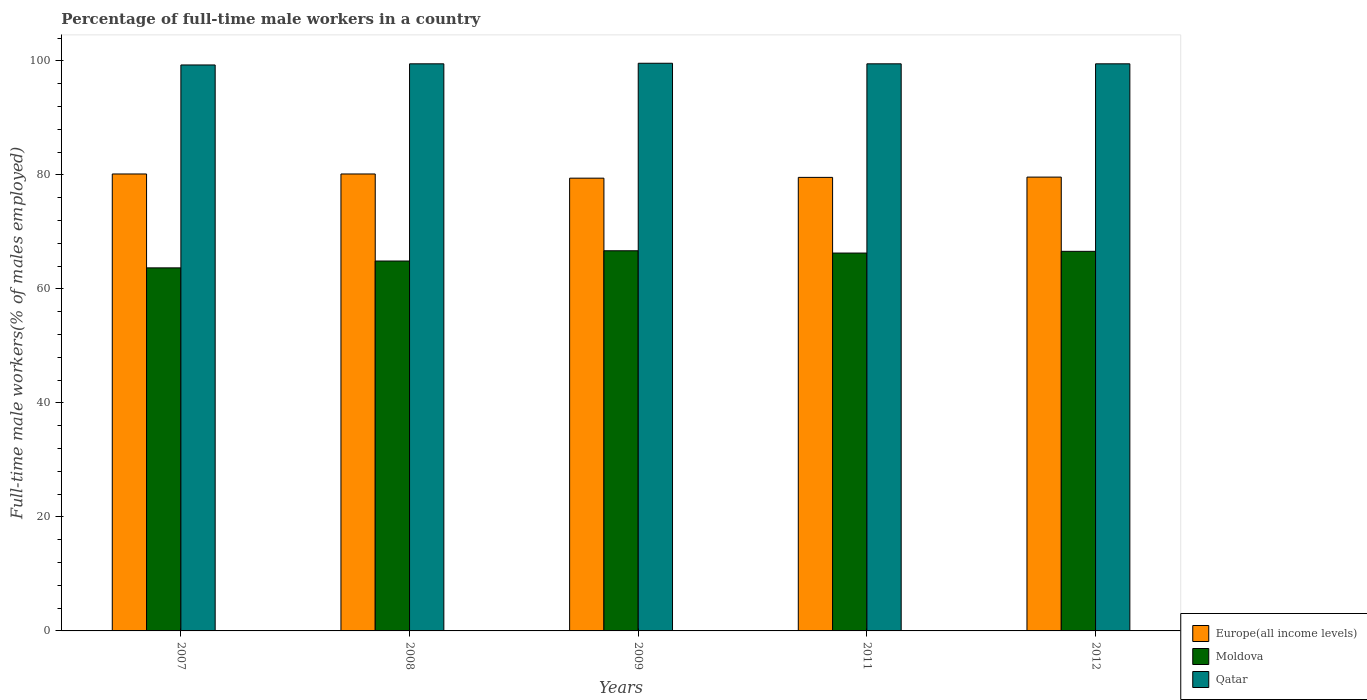How many different coloured bars are there?
Keep it short and to the point. 3. How many groups of bars are there?
Keep it short and to the point. 5. How many bars are there on the 4th tick from the left?
Provide a short and direct response. 3. What is the percentage of full-time male workers in Moldova in 2007?
Your response must be concise. 63.7. Across all years, what is the maximum percentage of full-time male workers in Qatar?
Give a very brief answer. 99.6. Across all years, what is the minimum percentage of full-time male workers in Europe(all income levels)?
Your answer should be compact. 79.44. In which year was the percentage of full-time male workers in Europe(all income levels) maximum?
Make the answer very short. 2007. What is the total percentage of full-time male workers in Europe(all income levels) in the graph?
Offer a terse response. 398.99. What is the difference between the percentage of full-time male workers in Moldova in 2009 and that in 2012?
Offer a very short reply. 0.1. What is the difference between the percentage of full-time male workers in Moldova in 2008 and the percentage of full-time male workers in Qatar in 2012?
Your answer should be compact. -34.6. What is the average percentage of full-time male workers in Qatar per year?
Provide a succinct answer. 99.48. In the year 2007, what is the difference between the percentage of full-time male workers in Qatar and percentage of full-time male workers in Europe(all income levels)?
Offer a terse response. 19.13. In how many years, is the percentage of full-time male workers in Europe(all income levels) greater than 68 %?
Keep it short and to the point. 5. What is the ratio of the percentage of full-time male workers in Europe(all income levels) in 2008 to that in 2012?
Provide a short and direct response. 1.01. What is the difference between the highest and the second highest percentage of full-time male workers in Europe(all income levels)?
Give a very brief answer. 0. What is the difference between the highest and the lowest percentage of full-time male workers in Europe(all income levels)?
Keep it short and to the point. 0.74. In how many years, is the percentage of full-time male workers in Moldova greater than the average percentage of full-time male workers in Moldova taken over all years?
Keep it short and to the point. 3. Is the sum of the percentage of full-time male workers in Europe(all income levels) in 2008 and 2011 greater than the maximum percentage of full-time male workers in Moldova across all years?
Give a very brief answer. Yes. What does the 1st bar from the left in 2008 represents?
Provide a short and direct response. Europe(all income levels). What does the 3rd bar from the right in 2012 represents?
Your answer should be compact. Europe(all income levels). How many bars are there?
Keep it short and to the point. 15. How many years are there in the graph?
Ensure brevity in your answer.  5. What is the difference between two consecutive major ticks on the Y-axis?
Your response must be concise. 20. Does the graph contain grids?
Provide a short and direct response. No. Where does the legend appear in the graph?
Ensure brevity in your answer.  Bottom right. How many legend labels are there?
Ensure brevity in your answer.  3. What is the title of the graph?
Keep it short and to the point. Percentage of full-time male workers in a country. What is the label or title of the X-axis?
Your answer should be compact. Years. What is the label or title of the Y-axis?
Provide a short and direct response. Full-time male workers(% of males employed). What is the Full-time male workers(% of males employed) of Europe(all income levels) in 2007?
Give a very brief answer. 80.17. What is the Full-time male workers(% of males employed) of Moldova in 2007?
Provide a short and direct response. 63.7. What is the Full-time male workers(% of males employed) of Qatar in 2007?
Make the answer very short. 99.3. What is the Full-time male workers(% of males employed) of Europe(all income levels) in 2008?
Your answer should be compact. 80.17. What is the Full-time male workers(% of males employed) of Moldova in 2008?
Offer a terse response. 64.9. What is the Full-time male workers(% of males employed) in Qatar in 2008?
Give a very brief answer. 99.5. What is the Full-time male workers(% of males employed) of Europe(all income levels) in 2009?
Make the answer very short. 79.44. What is the Full-time male workers(% of males employed) in Moldova in 2009?
Ensure brevity in your answer.  66.7. What is the Full-time male workers(% of males employed) in Qatar in 2009?
Ensure brevity in your answer.  99.6. What is the Full-time male workers(% of males employed) of Europe(all income levels) in 2011?
Give a very brief answer. 79.58. What is the Full-time male workers(% of males employed) of Moldova in 2011?
Your response must be concise. 66.3. What is the Full-time male workers(% of males employed) of Qatar in 2011?
Your answer should be compact. 99.5. What is the Full-time male workers(% of males employed) of Europe(all income levels) in 2012?
Your answer should be very brief. 79.63. What is the Full-time male workers(% of males employed) of Moldova in 2012?
Make the answer very short. 66.6. What is the Full-time male workers(% of males employed) in Qatar in 2012?
Your answer should be very brief. 99.5. Across all years, what is the maximum Full-time male workers(% of males employed) in Europe(all income levels)?
Ensure brevity in your answer.  80.17. Across all years, what is the maximum Full-time male workers(% of males employed) of Moldova?
Keep it short and to the point. 66.7. Across all years, what is the maximum Full-time male workers(% of males employed) in Qatar?
Keep it short and to the point. 99.6. Across all years, what is the minimum Full-time male workers(% of males employed) in Europe(all income levels)?
Provide a short and direct response. 79.44. Across all years, what is the minimum Full-time male workers(% of males employed) in Moldova?
Offer a terse response. 63.7. Across all years, what is the minimum Full-time male workers(% of males employed) in Qatar?
Make the answer very short. 99.3. What is the total Full-time male workers(% of males employed) in Europe(all income levels) in the graph?
Your answer should be very brief. 398.99. What is the total Full-time male workers(% of males employed) in Moldova in the graph?
Offer a very short reply. 328.2. What is the total Full-time male workers(% of males employed) in Qatar in the graph?
Make the answer very short. 497.4. What is the difference between the Full-time male workers(% of males employed) of Europe(all income levels) in 2007 and that in 2008?
Keep it short and to the point. 0. What is the difference between the Full-time male workers(% of males employed) of Moldova in 2007 and that in 2008?
Provide a succinct answer. -1.2. What is the difference between the Full-time male workers(% of males employed) of Qatar in 2007 and that in 2008?
Keep it short and to the point. -0.2. What is the difference between the Full-time male workers(% of males employed) in Europe(all income levels) in 2007 and that in 2009?
Provide a succinct answer. 0.74. What is the difference between the Full-time male workers(% of males employed) of Qatar in 2007 and that in 2009?
Ensure brevity in your answer.  -0.3. What is the difference between the Full-time male workers(% of males employed) of Europe(all income levels) in 2007 and that in 2011?
Ensure brevity in your answer.  0.6. What is the difference between the Full-time male workers(% of males employed) in Moldova in 2007 and that in 2011?
Provide a succinct answer. -2.6. What is the difference between the Full-time male workers(% of males employed) of Qatar in 2007 and that in 2011?
Ensure brevity in your answer.  -0.2. What is the difference between the Full-time male workers(% of males employed) of Europe(all income levels) in 2007 and that in 2012?
Provide a succinct answer. 0.55. What is the difference between the Full-time male workers(% of males employed) in Moldova in 2007 and that in 2012?
Provide a short and direct response. -2.9. What is the difference between the Full-time male workers(% of males employed) in Europe(all income levels) in 2008 and that in 2009?
Give a very brief answer. 0.74. What is the difference between the Full-time male workers(% of males employed) in Moldova in 2008 and that in 2009?
Keep it short and to the point. -1.8. What is the difference between the Full-time male workers(% of males employed) of Europe(all income levels) in 2008 and that in 2011?
Provide a succinct answer. 0.6. What is the difference between the Full-time male workers(% of males employed) of Moldova in 2008 and that in 2011?
Keep it short and to the point. -1.4. What is the difference between the Full-time male workers(% of males employed) in Qatar in 2008 and that in 2011?
Your response must be concise. 0. What is the difference between the Full-time male workers(% of males employed) of Europe(all income levels) in 2008 and that in 2012?
Offer a very short reply. 0.55. What is the difference between the Full-time male workers(% of males employed) in Moldova in 2008 and that in 2012?
Offer a very short reply. -1.7. What is the difference between the Full-time male workers(% of males employed) in Europe(all income levels) in 2009 and that in 2011?
Your answer should be very brief. -0.14. What is the difference between the Full-time male workers(% of males employed) in Europe(all income levels) in 2009 and that in 2012?
Keep it short and to the point. -0.19. What is the difference between the Full-time male workers(% of males employed) in Europe(all income levels) in 2011 and that in 2012?
Keep it short and to the point. -0.05. What is the difference between the Full-time male workers(% of males employed) of Europe(all income levels) in 2007 and the Full-time male workers(% of males employed) of Moldova in 2008?
Your response must be concise. 15.27. What is the difference between the Full-time male workers(% of males employed) of Europe(all income levels) in 2007 and the Full-time male workers(% of males employed) of Qatar in 2008?
Your answer should be compact. -19.33. What is the difference between the Full-time male workers(% of males employed) of Moldova in 2007 and the Full-time male workers(% of males employed) of Qatar in 2008?
Give a very brief answer. -35.8. What is the difference between the Full-time male workers(% of males employed) in Europe(all income levels) in 2007 and the Full-time male workers(% of males employed) in Moldova in 2009?
Make the answer very short. 13.47. What is the difference between the Full-time male workers(% of males employed) in Europe(all income levels) in 2007 and the Full-time male workers(% of males employed) in Qatar in 2009?
Ensure brevity in your answer.  -19.43. What is the difference between the Full-time male workers(% of males employed) of Moldova in 2007 and the Full-time male workers(% of males employed) of Qatar in 2009?
Make the answer very short. -35.9. What is the difference between the Full-time male workers(% of males employed) of Europe(all income levels) in 2007 and the Full-time male workers(% of males employed) of Moldova in 2011?
Give a very brief answer. 13.87. What is the difference between the Full-time male workers(% of males employed) of Europe(all income levels) in 2007 and the Full-time male workers(% of males employed) of Qatar in 2011?
Ensure brevity in your answer.  -19.33. What is the difference between the Full-time male workers(% of males employed) of Moldova in 2007 and the Full-time male workers(% of males employed) of Qatar in 2011?
Provide a succinct answer. -35.8. What is the difference between the Full-time male workers(% of males employed) of Europe(all income levels) in 2007 and the Full-time male workers(% of males employed) of Moldova in 2012?
Your response must be concise. 13.57. What is the difference between the Full-time male workers(% of males employed) of Europe(all income levels) in 2007 and the Full-time male workers(% of males employed) of Qatar in 2012?
Offer a terse response. -19.33. What is the difference between the Full-time male workers(% of males employed) of Moldova in 2007 and the Full-time male workers(% of males employed) of Qatar in 2012?
Provide a succinct answer. -35.8. What is the difference between the Full-time male workers(% of males employed) in Europe(all income levels) in 2008 and the Full-time male workers(% of males employed) in Moldova in 2009?
Your response must be concise. 13.47. What is the difference between the Full-time male workers(% of males employed) in Europe(all income levels) in 2008 and the Full-time male workers(% of males employed) in Qatar in 2009?
Offer a very short reply. -19.43. What is the difference between the Full-time male workers(% of males employed) in Moldova in 2008 and the Full-time male workers(% of males employed) in Qatar in 2009?
Give a very brief answer. -34.7. What is the difference between the Full-time male workers(% of males employed) in Europe(all income levels) in 2008 and the Full-time male workers(% of males employed) in Moldova in 2011?
Give a very brief answer. 13.87. What is the difference between the Full-time male workers(% of males employed) in Europe(all income levels) in 2008 and the Full-time male workers(% of males employed) in Qatar in 2011?
Give a very brief answer. -19.33. What is the difference between the Full-time male workers(% of males employed) of Moldova in 2008 and the Full-time male workers(% of males employed) of Qatar in 2011?
Your answer should be very brief. -34.6. What is the difference between the Full-time male workers(% of males employed) of Europe(all income levels) in 2008 and the Full-time male workers(% of males employed) of Moldova in 2012?
Make the answer very short. 13.57. What is the difference between the Full-time male workers(% of males employed) in Europe(all income levels) in 2008 and the Full-time male workers(% of males employed) in Qatar in 2012?
Give a very brief answer. -19.33. What is the difference between the Full-time male workers(% of males employed) in Moldova in 2008 and the Full-time male workers(% of males employed) in Qatar in 2012?
Your answer should be very brief. -34.6. What is the difference between the Full-time male workers(% of males employed) in Europe(all income levels) in 2009 and the Full-time male workers(% of males employed) in Moldova in 2011?
Your answer should be very brief. 13.14. What is the difference between the Full-time male workers(% of males employed) in Europe(all income levels) in 2009 and the Full-time male workers(% of males employed) in Qatar in 2011?
Ensure brevity in your answer.  -20.06. What is the difference between the Full-time male workers(% of males employed) of Moldova in 2009 and the Full-time male workers(% of males employed) of Qatar in 2011?
Offer a very short reply. -32.8. What is the difference between the Full-time male workers(% of males employed) of Europe(all income levels) in 2009 and the Full-time male workers(% of males employed) of Moldova in 2012?
Make the answer very short. 12.84. What is the difference between the Full-time male workers(% of males employed) in Europe(all income levels) in 2009 and the Full-time male workers(% of males employed) in Qatar in 2012?
Offer a very short reply. -20.06. What is the difference between the Full-time male workers(% of males employed) in Moldova in 2009 and the Full-time male workers(% of males employed) in Qatar in 2012?
Keep it short and to the point. -32.8. What is the difference between the Full-time male workers(% of males employed) in Europe(all income levels) in 2011 and the Full-time male workers(% of males employed) in Moldova in 2012?
Ensure brevity in your answer.  12.98. What is the difference between the Full-time male workers(% of males employed) of Europe(all income levels) in 2011 and the Full-time male workers(% of males employed) of Qatar in 2012?
Keep it short and to the point. -19.92. What is the difference between the Full-time male workers(% of males employed) of Moldova in 2011 and the Full-time male workers(% of males employed) of Qatar in 2012?
Offer a terse response. -33.2. What is the average Full-time male workers(% of males employed) in Europe(all income levels) per year?
Give a very brief answer. 79.8. What is the average Full-time male workers(% of males employed) of Moldova per year?
Keep it short and to the point. 65.64. What is the average Full-time male workers(% of males employed) in Qatar per year?
Provide a short and direct response. 99.48. In the year 2007, what is the difference between the Full-time male workers(% of males employed) of Europe(all income levels) and Full-time male workers(% of males employed) of Moldova?
Your response must be concise. 16.47. In the year 2007, what is the difference between the Full-time male workers(% of males employed) in Europe(all income levels) and Full-time male workers(% of males employed) in Qatar?
Your answer should be very brief. -19.13. In the year 2007, what is the difference between the Full-time male workers(% of males employed) of Moldova and Full-time male workers(% of males employed) of Qatar?
Your answer should be compact. -35.6. In the year 2008, what is the difference between the Full-time male workers(% of males employed) in Europe(all income levels) and Full-time male workers(% of males employed) in Moldova?
Keep it short and to the point. 15.27. In the year 2008, what is the difference between the Full-time male workers(% of males employed) in Europe(all income levels) and Full-time male workers(% of males employed) in Qatar?
Your response must be concise. -19.33. In the year 2008, what is the difference between the Full-time male workers(% of males employed) in Moldova and Full-time male workers(% of males employed) in Qatar?
Provide a short and direct response. -34.6. In the year 2009, what is the difference between the Full-time male workers(% of males employed) of Europe(all income levels) and Full-time male workers(% of males employed) of Moldova?
Provide a short and direct response. 12.74. In the year 2009, what is the difference between the Full-time male workers(% of males employed) of Europe(all income levels) and Full-time male workers(% of males employed) of Qatar?
Offer a very short reply. -20.16. In the year 2009, what is the difference between the Full-time male workers(% of males employed) in Moldova and Full-time male workers(% of males employed) in Qatar?
Ensure brevity in your answer.  -32.9. In the year 2011, what is the difference between the Full-time male workers(% of males employed) in Europe(all income levels) and Full-time male workers(% of males employed) in Moldova?
Keep it short and to the point. 13.28. In the year 2011, what is the difference between the Full-time male workers(% of males employed) of Europe(all income levels) and Full-time male workers(% of males employed) of Qatar?
Make the answer very short. -19.92. In the year 2011, what is the difference between the Full-time male workers(% of males employed) of Moldova and Full-time male workers(% of males employed) of Qatar?
Make the answer very short. -33.2. In the year 2012, what is the difference between the Full-time male workers(% of males employed) of Europe(all income levels) and Full-time male workers(% of males employed) of Moldova?
Your answer should be very brief. 13.03. In the year 2012, what is the difference between the Full-time male workers(% of males employed) of Europe(all income levels) and Full-time male workers(% of males employed) of Qatar?
Provide a succinct answer. -19.87. In the year 2012, what is the difference between the Full-time male workers(% of males employed) in Moldova and Full-time male workers(% of males employed) in Qatar?
Offer a terse response. -32.9. What is the ratio of the Full-time male workers(% of males employed) of Europe(all income levels) in 2007 to that in 2008?
Provide a short and direct response. 1. What is the ratio of the Full-time male workers(% of males employed) in Moldova in 2007 to that in 2008?
Your answer should be very brief. 0.98. What is the ratio of the Full-time male workers(% of males employed) in Europe(all income levels) in 2007 to that in 2009?
Your response must be concise. 1.01. What is the ratio of the Full-time male workers(% of males employed) of Moldova in 2007 to that in 2009?
Your response must be concise. 0.95. What is the ratio of the Full-time male workers(% of males employed) of Qatar in 2007 to that in 2009?
Your answer should be compact. 1. What is the ratio of the Full-time male workers(% of males employed) in Europe(all income levels) in 2007 to that in 2011?
Provide a succinct answer. 1.01. What is the ratio of the Full-time male workers(% of males employed) of Moldova in 2007 to that in 2011?
Offer a very short reply. 0.96. What is the ratio of the Full-time male workers(% of males employed) of Qatar in 2007 to that in 2011?
Your answer should be very brief. 1. What is the ratio of the Full-time male workers(% of males employed) in Europe(all income levels) in 2007 to that in 2012?
Make the answer very short. 1.01. What is the ratio of the Full-time male workers(% of males employed) of Moldova in 2007 to that in 2012?
Your answer should be compact. 0.96. What is the ratio of the Full-time male workers(% of males employed) of Europe(all income levels) in 2008 to that in 2009?
Give a very brief answer. 1.01. What is the ratio of the Full-time male workers(% of males employed) in Moldova in 2008 to that in 2009?
Your answer should be very brief. 0.97. What is the ratio of the Full-time male workers(% of males employed) of Qatar in 2008 to that in 2009?
Your answer should be very brief. 1. What is the ratio of the Full-time male workers(% of males employed) in Europe(all income levels) in 2008 to that in 2011?
Your answer should be very brief. 1.01. What is the ratio of the Full-time male workers(% of males employed) in Moldova in 2008 to that in 2011?
Provide a succinct answer. 0.98. What is the ratio of the Full-time male workers(% of males employed) in Europe(all income levels) in 2008 to that in 2012?
Your answer should be compact. 1.01. What is the ratio of the Full-time male workers(% of males employed) in Moldova in 2008 to that in 2012?
Ensure brevity in your answer.  0.97. What is the ratio of the Full-time male workers(% of males employed) of Qatar in 2008 to that in 2012?
Provide a succinct answer. 1. What is the ratio of the Full-time male workers(% of males employed) in Moldova in 2009 to that in 2012?
Keep it short and to the point. 1. What is the ratio of the Full-time male workers(% of males employed) in Qatar in 2009 to that in 2012?
Provide a succinct answer. 1. What is the ratio of the Full-time male workers(% of males employed) of Europe(all income levels) in 2011 to that in 2012?
Provide a short and direct response. 1. What is the ratio of the Full-time male workers(% of males employed) of Moldova in 2011 to that in 2012?
Make the answer very short. 1. What is the ratio of the Full-time male workers(% of males employed) in Qatar in 2011 to that in 2012?
Your answer should be very brief. 1. What is the difference between the highest and the second highest Full-time male workers(% of males employed) in Europe(all income levels)?
Provide a short and direct response. 0. What is the difference between the highest and the lowest Full-time male workers(% of males employed) in Europe(all income levels)?
Give a very brief answer. 0.74. What is the difference between the highest and the lowest Full-time male workers(% of males employed) of Moldova?
Ensure brevity in your answer.  3. 